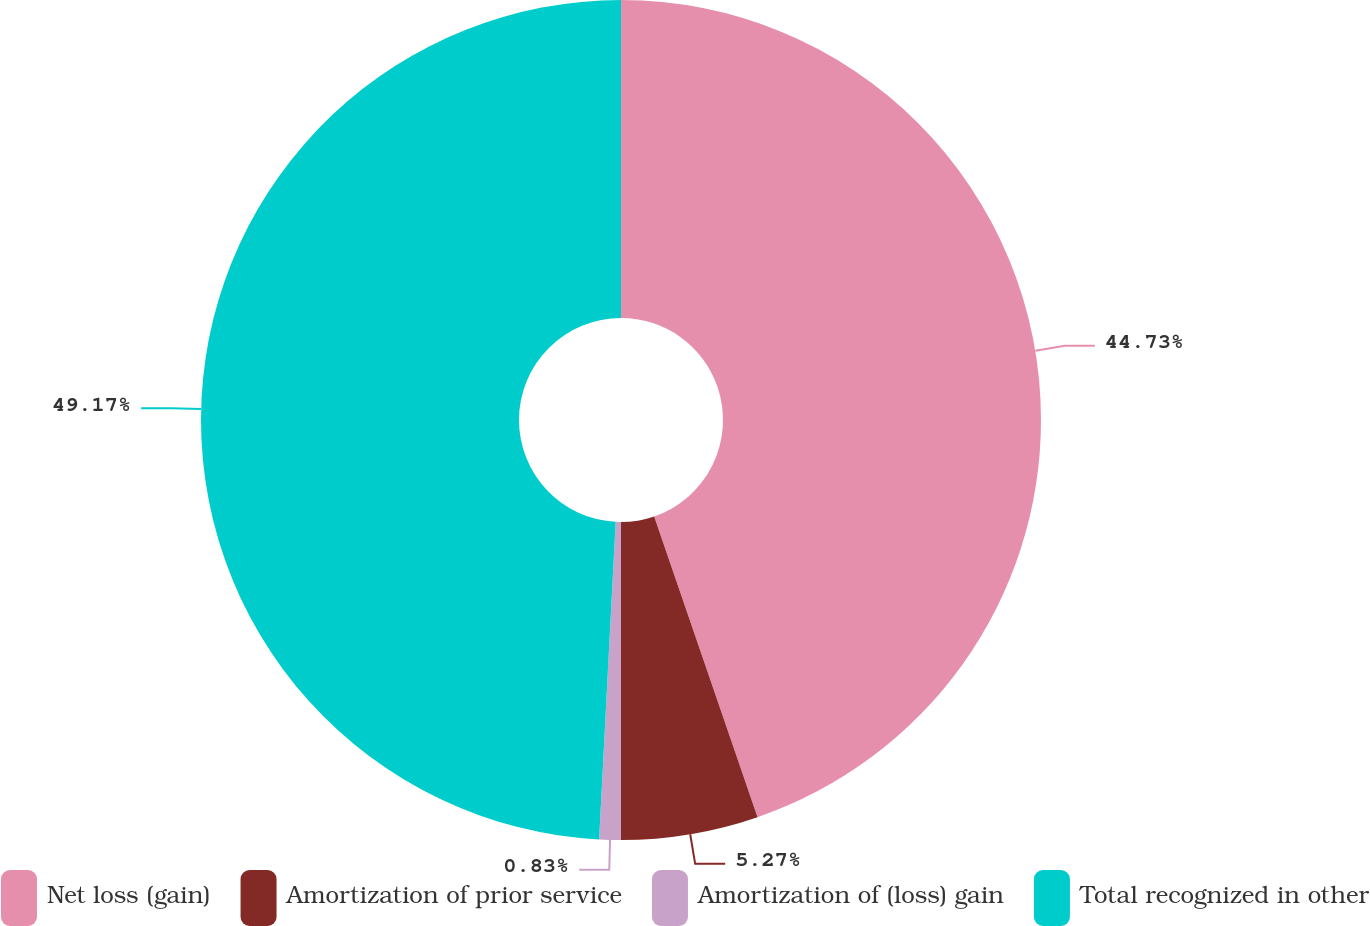Convert chart to OTSL. <chart><loc_0><loc_0><loc_500><loc_500><pie_chart><fcel>Net loss (gain)<fcel>Amortization of prior service<fcel>Amortization of (loss) gain<fcel>Total recognized in other<nl><fcel>44.73%<fcel>5.27%<fcel>0.83%<fcel>49.17%<nl></chart> 